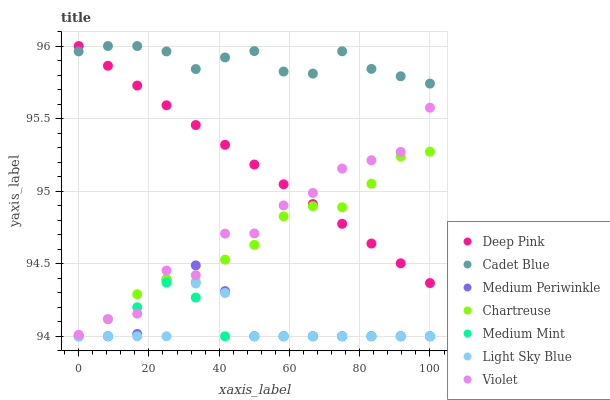Does Light Sky Blue have the minimum area under the curve?
Answer yes or no. Yes. Does Cadet Blue have the maximum area under the curve?
Answer yes or no. Yes. Does Medium Periwinkle have the minimum area under the curve?
Answer yes or no. No. Does Medium Periwinkle have the maximum area under the curve?
Answer yes or no. No. Is Deep Pink the smoothest?
Answer yes or no. Yes. Is Violet the roughest?
Answer yes or no. Yes. Is Cadet Blue the smoothest?
Answer yes or no. No. Is Cadet Blue the roughest?
Answer yes or no. No. Does Medium Mint have the lowest value?
Answer yes or no. Yes. Does Cadet Blue have the lowest value?
Answer yes or no. No. Does Deep Pink have the highest value?
Answer yes or no. Yes. Does Medium Periwinkle have the highest value?
Answer yes or no. No. Is Violet less than Cadet Blue?
Answer yes or no. Yes. Is Deep Pink greater than Medium Mint?
Answer yes or no. Yes. Does Deep Pink intersect Violet?
Answer yes or no. Yes. Is Deep Pink less than Violet?
Answer yes or no. No. Is Deep Pink greater than Violet?
Answer yes or no. No. Does Violet intersect Cadet Blue?
Answer yes or no. No. 